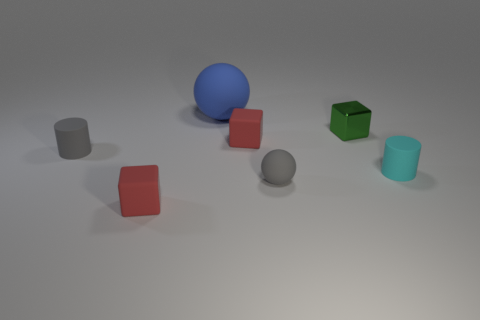Subtract all tiny shiny cubes. How many cubes are left? 2 Add 1 tiny cyan rubber cubes. How many objects exist? 8 Subtract all brown cylinders. How many red cubes are left? 2 Subtract all blue balls. How many balls are left? 1 Subtract 1 blue spheres. How many objects are left? 6 Subtract all cubes. How many objects are left? 4 Subtract 1 cylinders. How many cylinders are left? 1 Subtract all purple spheres. Subtract all purple cylinders. How many spheres are left? 2 Subtract all matte things. Subtract all green matte things. How many objects are left? 1 Add 4 small red matte things. How many small red matte things are left? 6 